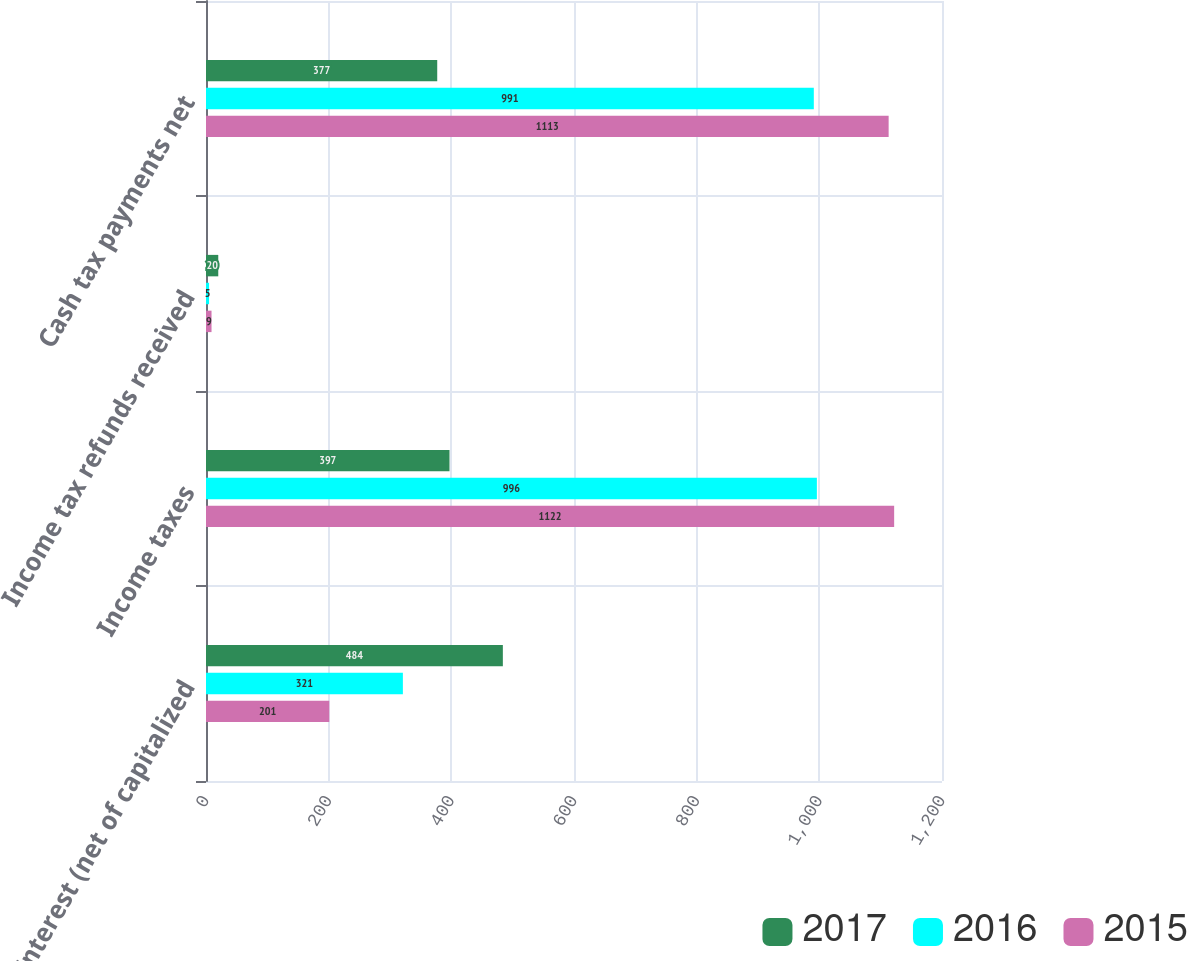Convert chart to OTSL. <chart><loc_0><loc_0><loc_500><loc_500><stacked_bar_chart><ecel><fcel>Interest (net of capitalized<fcel>Income taxes<fcel>Income tax refunds received<fcel>Cash tax payments net<nl><fcel>2017<fcel>484<fcel>397<fcel>20<fcel>377<nl><fcel>2016<fcel>321<fcel>996<fcel>5<fcel>991<nl><fcel>2015<fcel>201<fcel>1122<fcel>9<fcel>1113<nl></chart> 